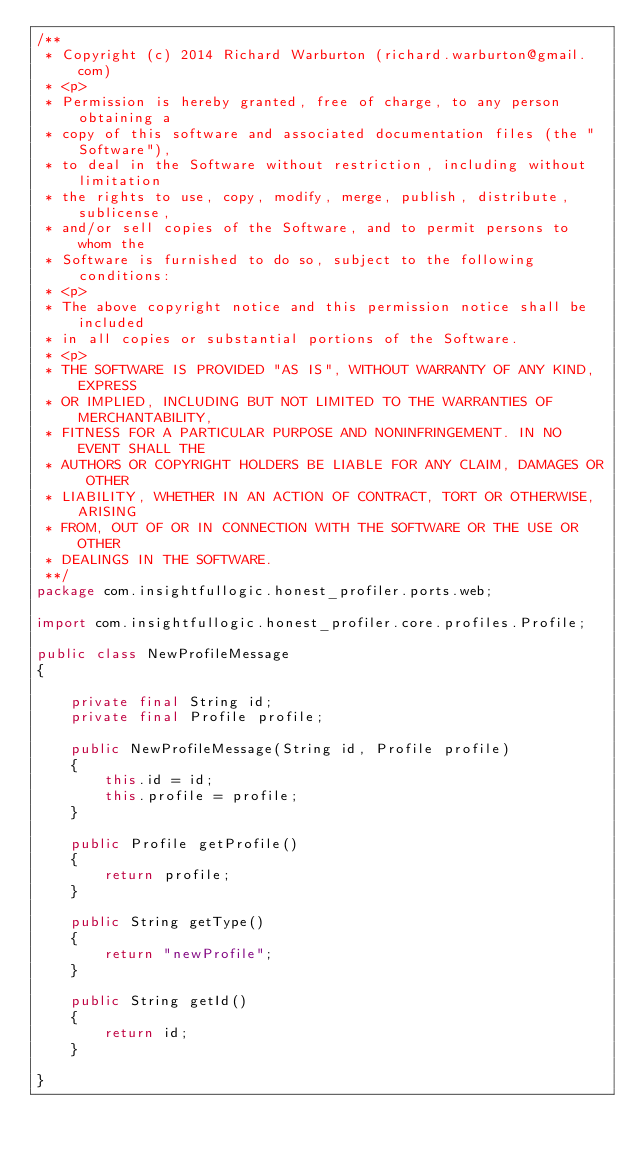<code> <loc_0><loc_0><loc_500><loc_500><_Java_>/**
 * Copyright (c) 2014 Richard Warburton (richard.warburton@gmail.com)
 * <p>
 * Permission is hereby granted, free of charge, to any person obtaining a
 * copy of this software and associated documentation files (the "Software"),
 * to deal in the Software without restriction, including without limitation
 * the rights to use, copy, modify, merge, publish, distribute, sublicense,
 * and/or sell copies of the Software, and to permit persons to whom the
 * Software is furnished to do so, subject to the following conditions:
 * <p>
 * The above copyright notice and this permission notice shall be included
 * in all copies or substantial portions of the Software.
 * <p>
 * THE SOFTWARE IS PROVIDED "AS IS", WITHOUT WARRANTY OF ANY KIND, EXPRESS
 * OR IMPLIED, INCLUDING BUT NOT LIMITED TO THE WARRANTIES OF MERCHANTABILITY,
 * FITNESS FOR A PARTICULAR PURPOSE AND NONINFRINGEMENT. IN NO EVENT SHALL THE
 * AUTHORS OR COPYRIGHT HOLDERS BE LIABLE FOR ANY CLAIM, DAMAGES OR OTHER
 * LIABILITY, WHETHER IN AN ACTION OF CONTRACT, TORT OR OTHERWISE, ARISING
 * FROM, OUT OF OR IN CONNECTION WITH THE SOFTWARE OR THE USE OR OTHER
 * DEALINGS IN THE SOFTWARE.
 **/
package com.insightfullogic.honest_profiler.ports.web;

import com.insightfullogic.honest_profiler.core.profiles.Profile;

public class NewProfileMessage
{

    private final String id;
    private final Profile profile;

    public NewProfileMessage(String id, Profile profile)
    {
        this.id = id;
        this.profile = profile;
    }

    public Profile getProfile()
    {
        return profile;
    }

    public String getType()
    {
        return "newProfile";
    }

    public String getId()
    {
        return id;
    }

}
</code> 